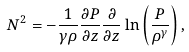<formula> <loc_0><loc_0><loc_500><loc_500>N ^ { 2 } = - \frac { 1 } { \gamma \rho } \frac { \partial P } { \partial z } \frac { \partial } { \partial z } \ln \left ( \frac { P } { \rho ^ { \gamma } } \right ) ,</formula> 